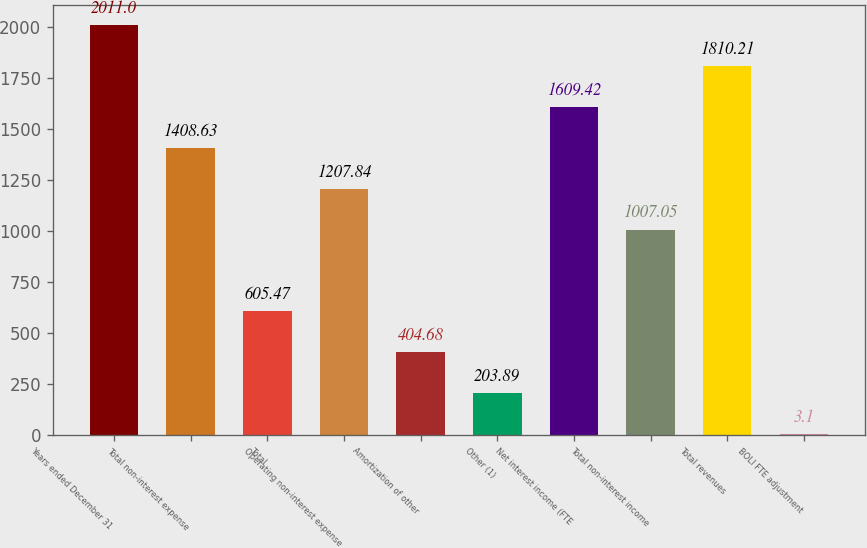<chart> <loc_0><loc_0><loc_500><loc_500><bar_chart><fcel>Years ended December 31<fcel>Total non-interest expense<fcel>Total<fcel>Operating non-interest expense<fcel>Amortization of other<fcel>Other (1)<fcel>Net interest income (FTE<fcel>Total non-interest income<fcel>Total revenues<fcel>BOLI FTE adjustment<nl><fcel>2011<fcel>1408.63<fcel>605.47<fcel>1207.84<fcel>404.68<fcel>203.89<fcel>1609.42<fcel>1007.05<fcel>1810.21<fcel>3.1<nl></chart> 